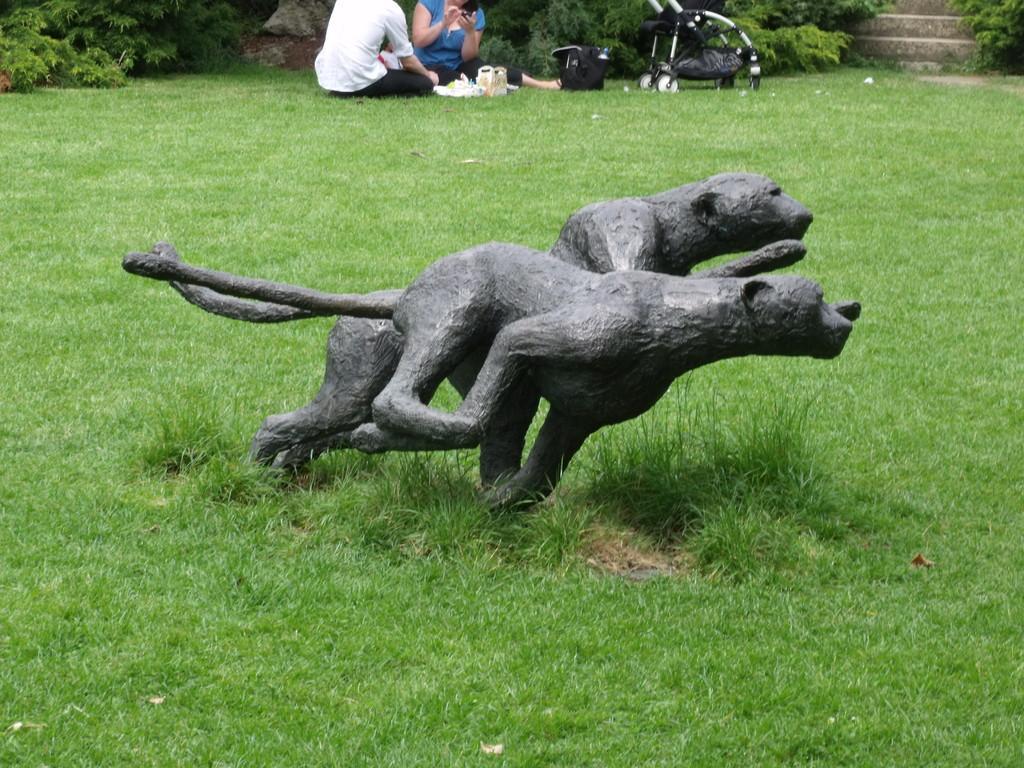Could you give a brief overview of what you see in this image? In the center of the image we can see a sculpture. At the top there are two people sitting on the grass. There is a trolley and a bag. We can see plants and there are stairs. There is grass. 